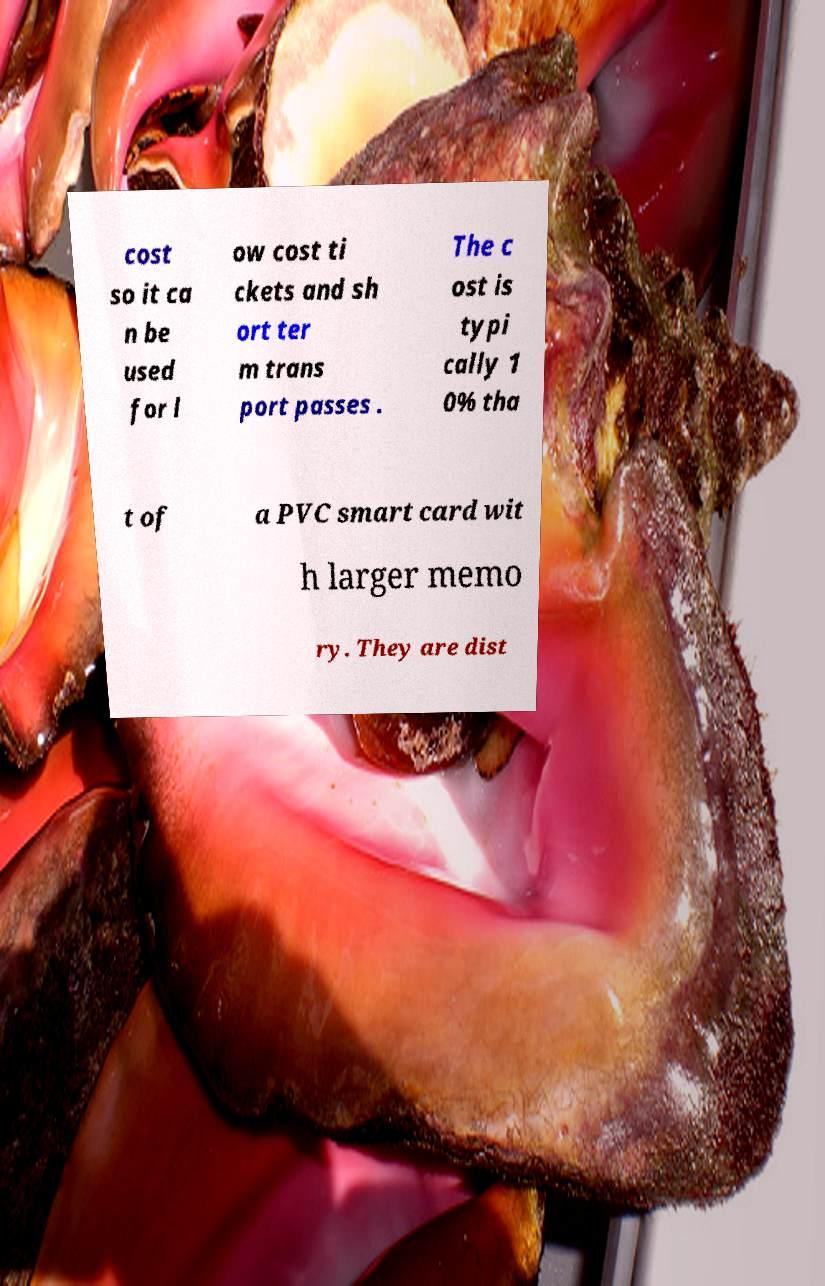What messages or text are displayed in this image? I need them in a readable, typed format. cost so it ca n be used for l ow cost ti ckets and sh ort ter m trans port passes . The c ost is typi cally 1 0% tha t of a PVC smart card wit h larger memo ry. They are dist 